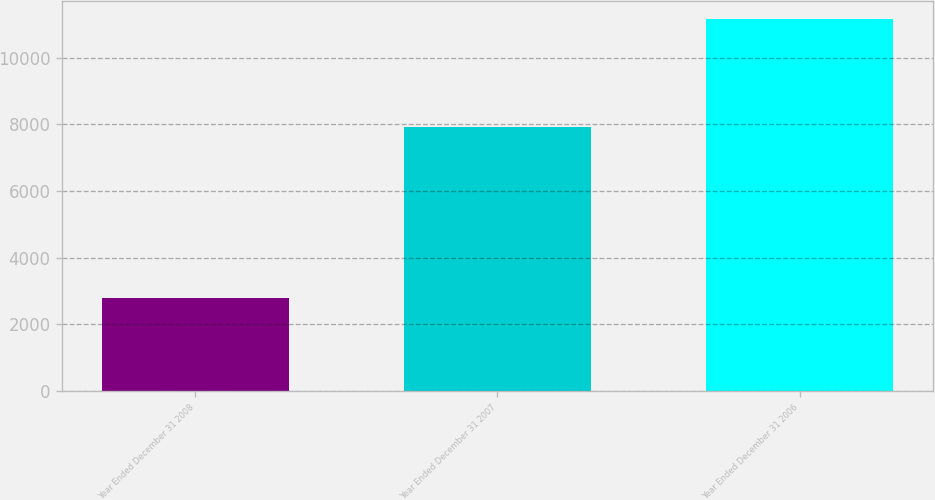<chart> <loc_0><loc_0><loc_500><loc_500><bar_chart><fcel>Year Ended December 31 2008<fcel>Year Ended December 31 2007<fcel>Year Ended December 31 2006<nl><fcel>2797.8<fcel>7904<fcel>11150<nl></chart> 